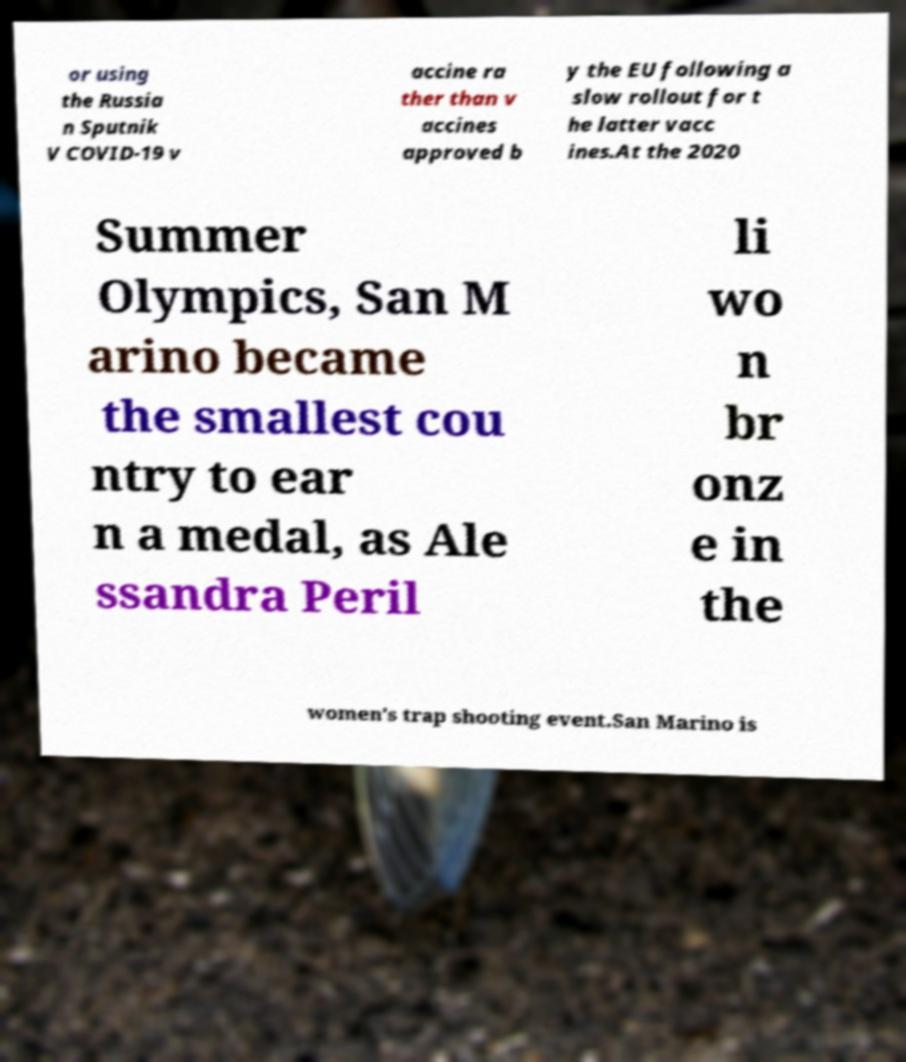Can you accurately transcribe the text from the provided image for me? or using the Russia n Sputnik V COVID-19 v accine ra ther than v accines approved b y the EU following a slow rollout for t he latter vacc ines.At the 2020 Summer Olympics, San M arino became the smallest cou ntry to ear n a medal, as Ale ssandra Peril li wo n br onz e in the women's trap shooting event.San Marino is 